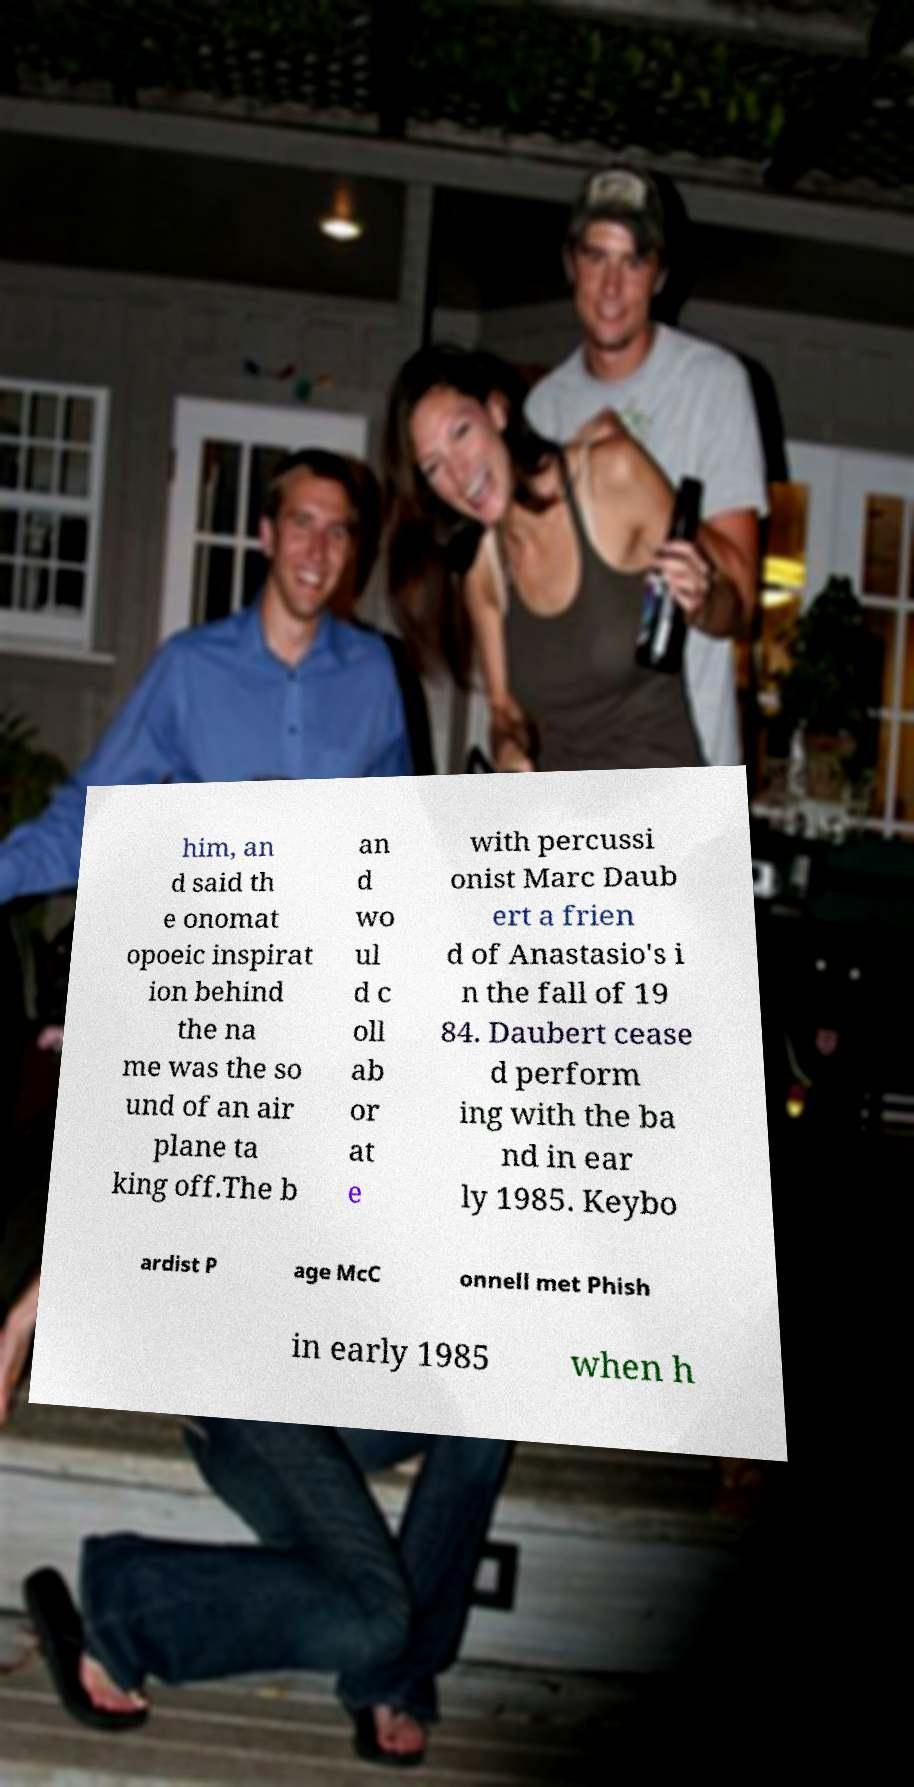Can you read and provide the text displayed in the image?This photo seems to have some interesting text. Can you extract and type it out for me? him, an d said th e onomat opoeic inspirat ion behind the na me was the so und of an air plane ta king off.The b an d wo ul d c oll ab or at e with percussi onist Marc Daub ert a frien d of Anastasio's i n the fall of 19 84. Daubert cease d perform ing with the ba nd in ear ly 1985. Keybo ardist P age McC onnell met Phish in early 1985 when h 